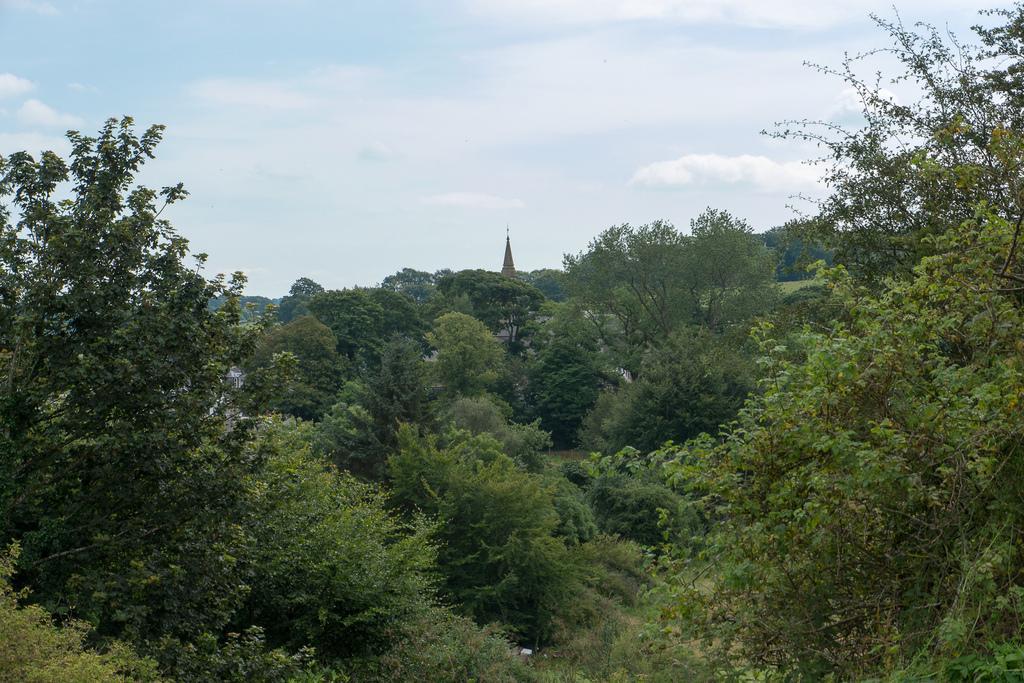How would you summarize this image in a sentence or two? In this picture we can see trees, top of a tower and in the background we can see the sky with clouds. 